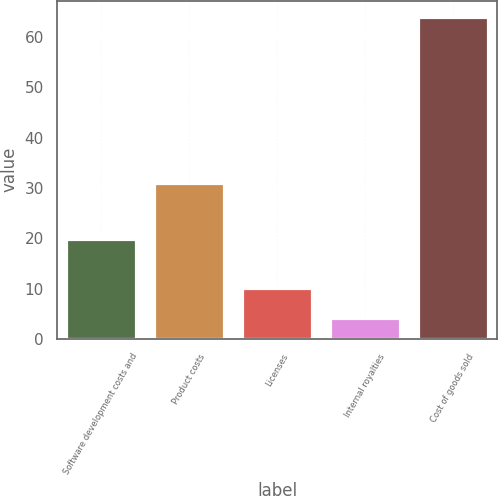Convert chart. <chart><loc_0><loc_0><loc_500><loc_500><bar_chart><fcel>Software development costs and<fcel>Product costs<fcel>Licenses<fcel>Internal royalties<fcel>Cost of goods sold<nl><fcel>19.9<fcel>30.9<fcel>10.09<fcel>4.1<fcel>64<nl></chart> 